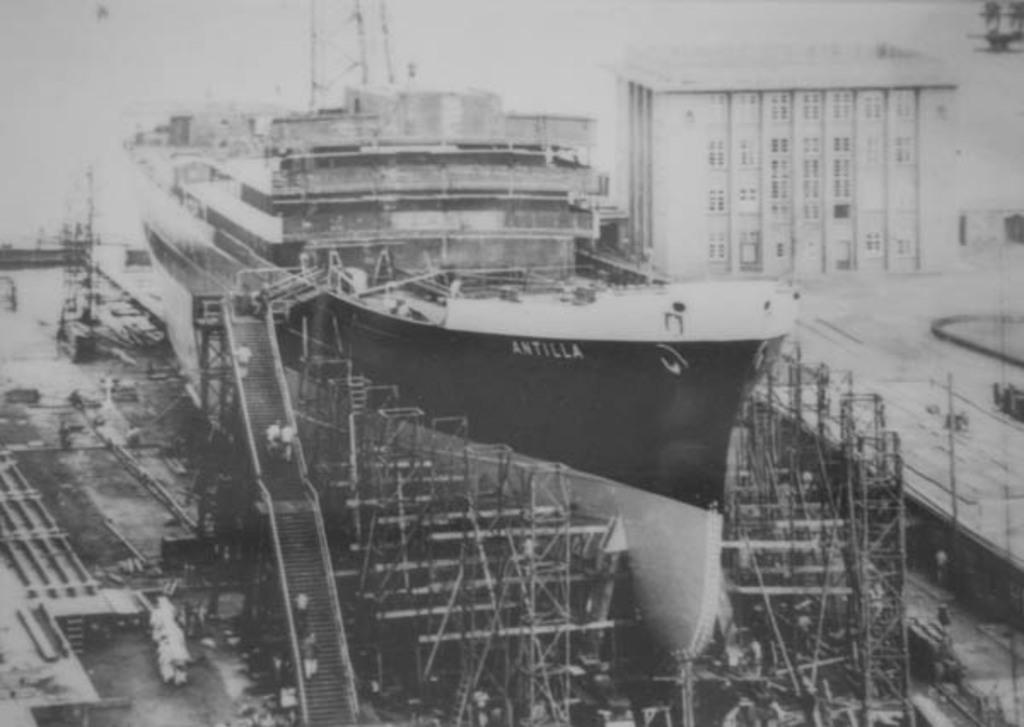<image>
Describe the image concisely. A huge ship under construction that says Antilla near the helm. 